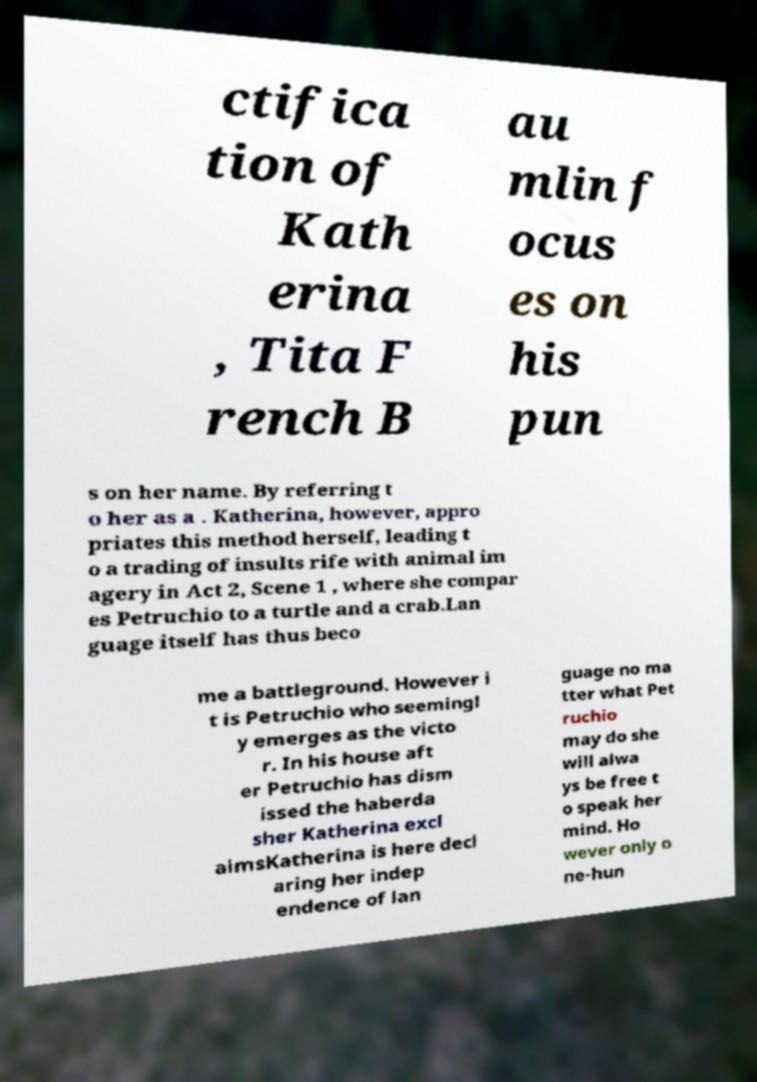What messages or text are displayed in this image? I need them in a readable, typed format. ctifica tion of Kath erina , Tita F rench B au mlin f ocus es on his pun s on her name. By referring t o her as a . Katherina, however, appro priates this method herself, leading t o a trading of insults rife with animal im agery in Act 2, Scene 1 , where she compar es Petruchio to a turtle and a crab.Lan guage itself has thus beco me a battleground. However i t is Petruchio who seemingl y emerges as the victo r. In his house aft er Petruchio has dism issed the haberda sher Katherina excl aimsKatherina is here decl aring her indep endence of lan guage no ma tter what Pet ruchio may do she will alwa ys be free t o speak her mind. Ho wever only o ne-hun 